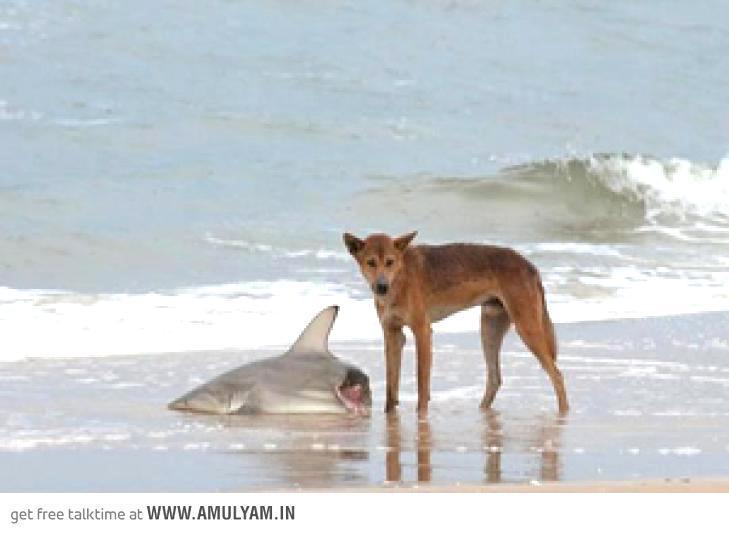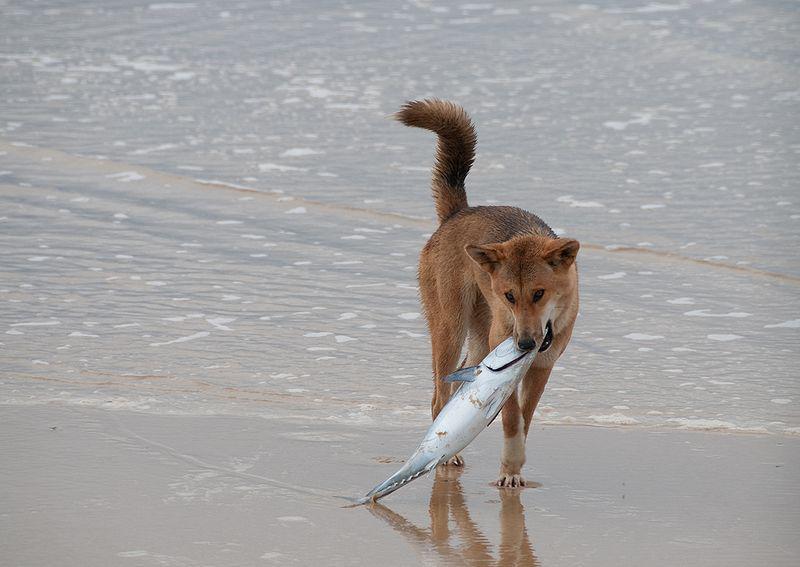The first image is the image on the left, the second image is the image on the right. Evaluate the accuracy of this statement regarding the images: "The front half of one shark is lying in the sand.". Is it true? Answer yes or no. Yes. 